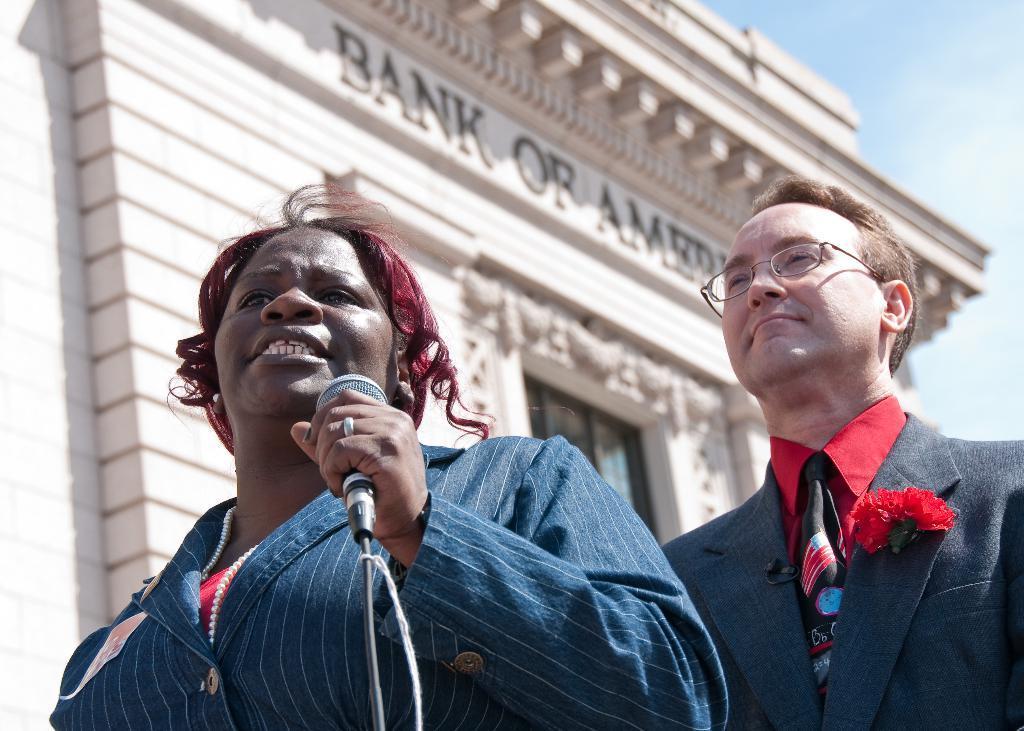In one or two sentences, can you explain what this image depicts? In this picture there is a lady who is holding a mic and behind there is a man who are standing in front of Bank of Baroda. 